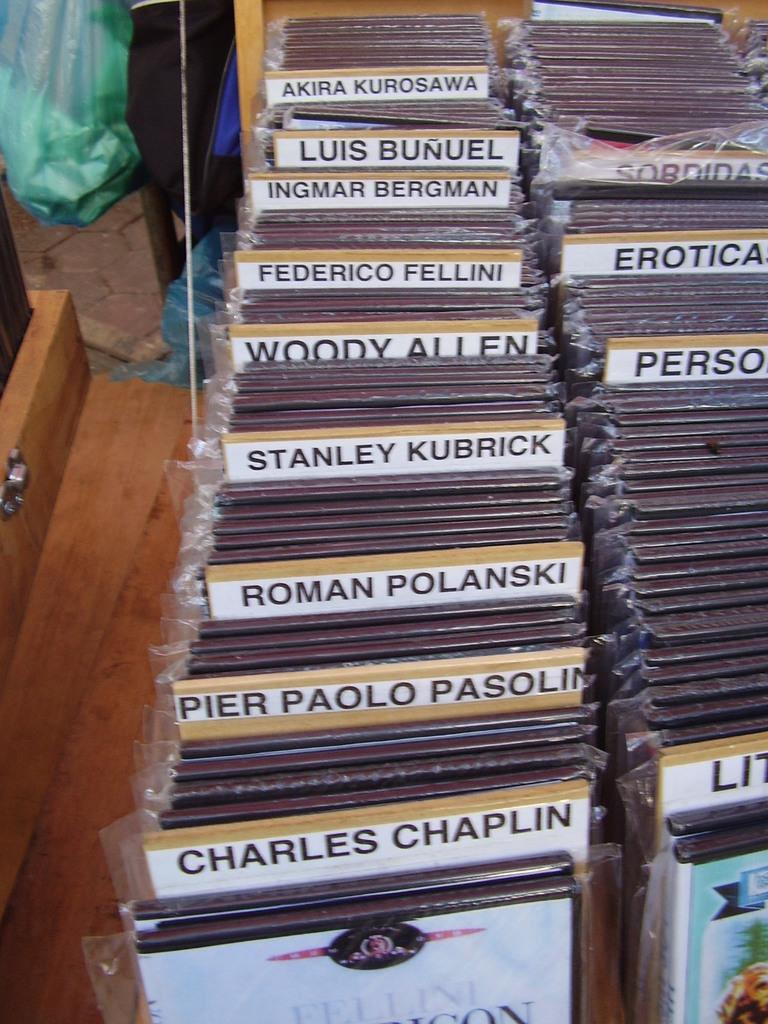<image>
Provide a brief description of the given image. A display case of movie by people like woody Allen and Charles chaplin. 